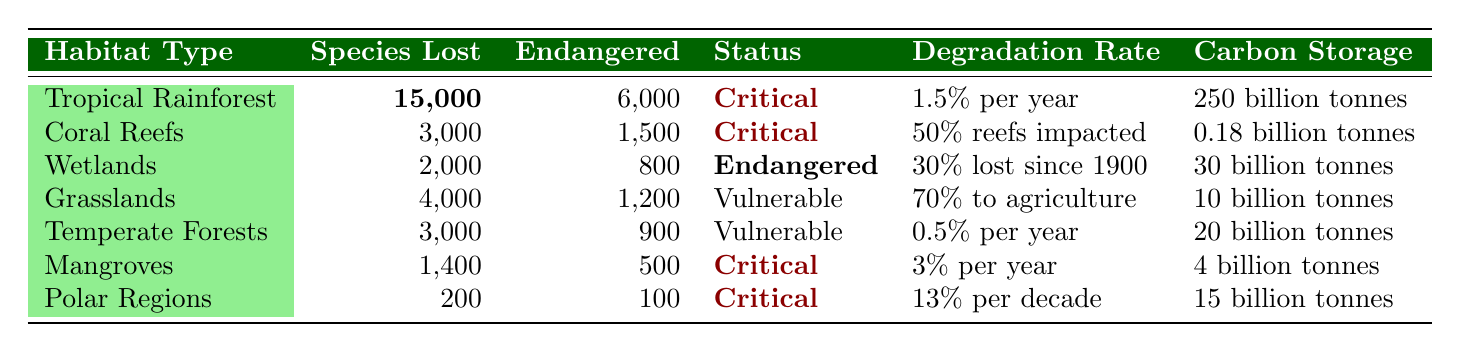What is the species loss in Tropical Rainforest? In the table, under the row for "Tropical Rainforest," the value for species lost is bolded and written as 15,000.
Answer: 15,000 How many endangered species are found in Coral Reefs? Looking at the row for "Coral Reefs," the number of endangered species listed is 1,500, which is shown in the table.
Answer: 1,500 Which habitat type has the highest carbon storage? The table shows that "Tropical Rainforest" has 250 billion tonnes of carbon storage, which is higher than any other habitat type listed in the table.
Answer: Tropical Rainforest Is the conservation status of Grasslands vulnerable? The table indicates that Grasslands have the conservation status of "Vulnerable," confirming the statement is true.
Answer: Yes How many species are lost in Wetlands compared to Grasslands? The table shows 2,000 species lost in Wetlands and 4,000 in Grasslands. The difference is 4,000 - 2,000 = 2,000 species.
Answer: 2,000 What is the total species lost across all habitat types? By summing the species lost across all rows: 15,000 (Tropical Rainforest) + 3,000 (Coral Reefs) + 2,000 (Wetlands) + 4,000 (Grasslands) + 3,000 (Temperate Forests) + 1,400 (Mangroves) + 200 (Polar Regions) = 28,600.
Answer: 28,600 Which habitat type has the highest rate of deforestation? The table shows that Mangroves have a deforestation rate of 3% per year, while Tropical Rainforest has 1.5% per year. Since 3% is higher, it indicates Mangroves have the highest rate.
Answer: Mangroves How many endangered species are found across all habitats? Totaling the endangered species: 6,000 (Tropical Rainforest) + 1,500 (Coral Reefs) + 800 (Wetlands) + 1,200 (Grasslands) + 900 (Temperate Forests) + 500 (Mangroves) + 100 (Polar Regions) gives a total of 12,100.
Answer: 12,100 Which habitat has the lowest amount of carbon storage? Looking at the carbon storage values, Coral Reefs have the lowest at 0.18 billion tonnes, while others have significantly higher values.
Answer: Coral Reefs How does the species loss in Polar Regions compare to that in Wetlands? The species loss in Polar Regions is 200, while in Wetlands it is 2,000. The difference is 2,000 - 200 = 1,800, showing significantly higher loss in Wetlands.
Answer: 1,800 